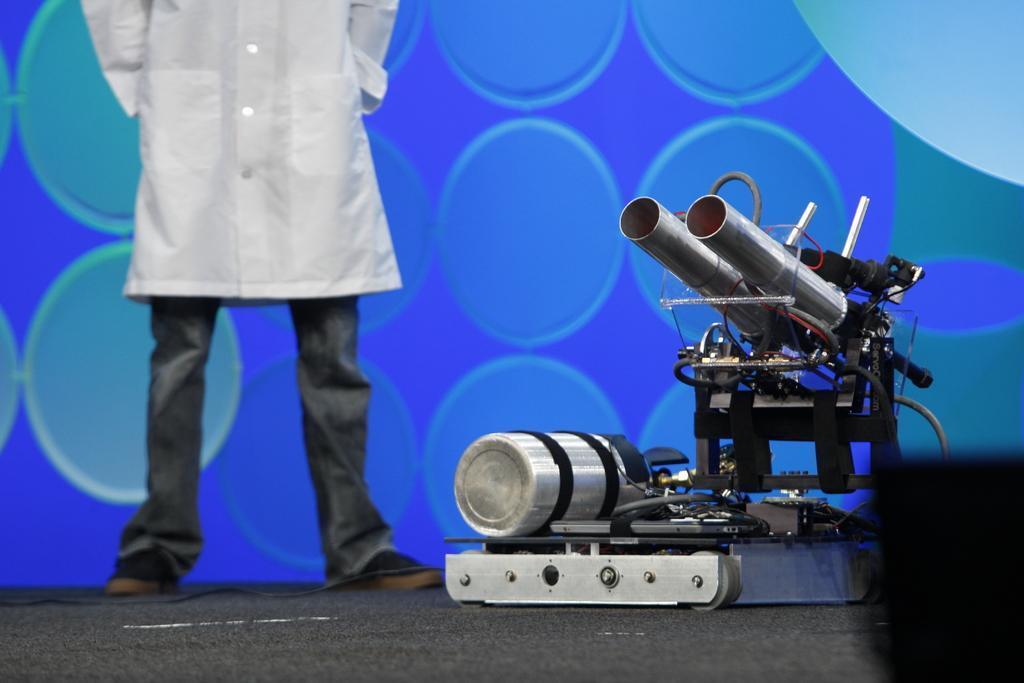In one or two sentences, can you explain what this image depicts? In this image I see an equipment over here and I see a person over here who is wearing white shirt and black pants and I see a wire over here and I see that it is blue and green color in the background. 